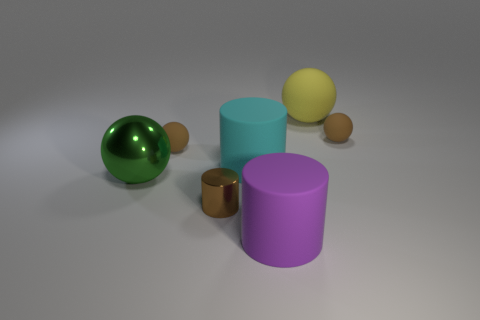There is a big thing in front of the green sphere; what color is it?
Offer a terse response. Purple. Does the brown cylinder have the same size as the cyan cylinder?
Your answer should be compact. No. What is the material of the big sphere behind the brown matte object that is to the right of the yellow ball?
Offer a terse response. Rubber. How many tiny matte spheres have the same color as the tiny cylinder?
Ensure brevity in your answer.  2. Are there fewer big cyan matte things that are on the right side of the yellow rubber object than small brown things?
Ensure brevity in your answer.  Yes. The large sphere that is in front of the brown matte object that is right of the large cyan cylinder is what color?
Provide a succinct answer. Green. What size is the cylinder left of the cyan rubber cylinder in front of the tiny brown rubber ball that is to the left of the purple object?
Keep it short and to the point. Small. Are there fewer purple rubber cylinders behind the big green object than matte objects that are in front of the cyan rubber thing?
Keep it short and to the point. Yes. How many big cyan objects are the same material as the large purple thing?
Keep it short and to the point. 1. There is a tiny matte object right of the big ball that is to the right of the green metal object; are there any brown things in front of it?
Your response must be concise. Yes. 